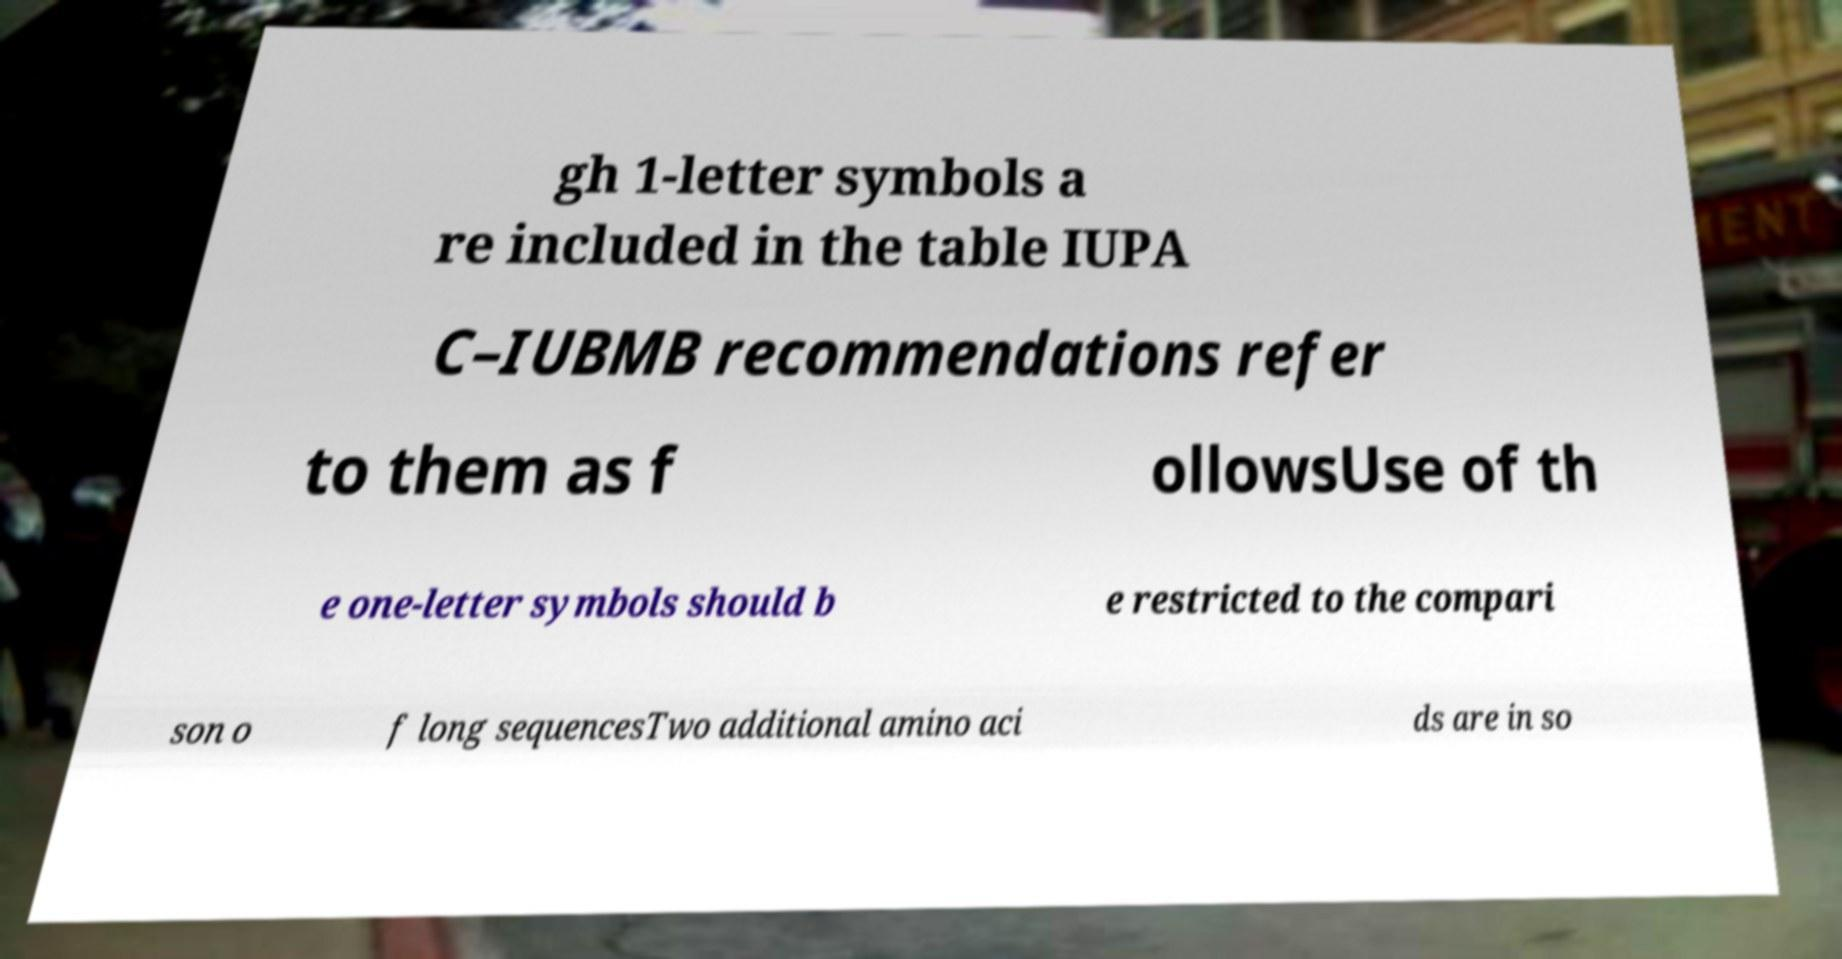For documentation purposes, I need the text within this image transcribed. Could you provide that? gh 1-letter symbols a re included in the table IUPA C–IUBMB recommendations refer to them as f ollowsUse of th e one-letter symbols should b e restricted to the compari son o f long sequencesTwo additional amino aci ds are in so 